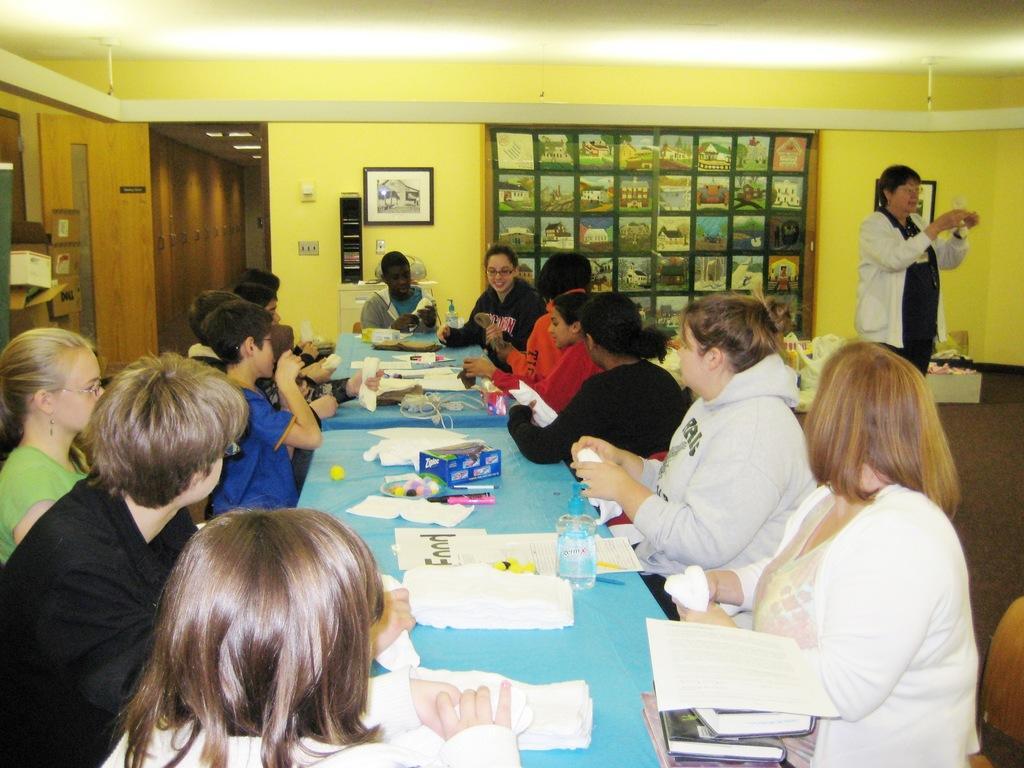In one or two sentences, can you explain what this image depicts? In the image we can see there are lot of people who are sitting on chair and on table there are papers, water bottle, pen, marker and on the wall there are photo frames. 